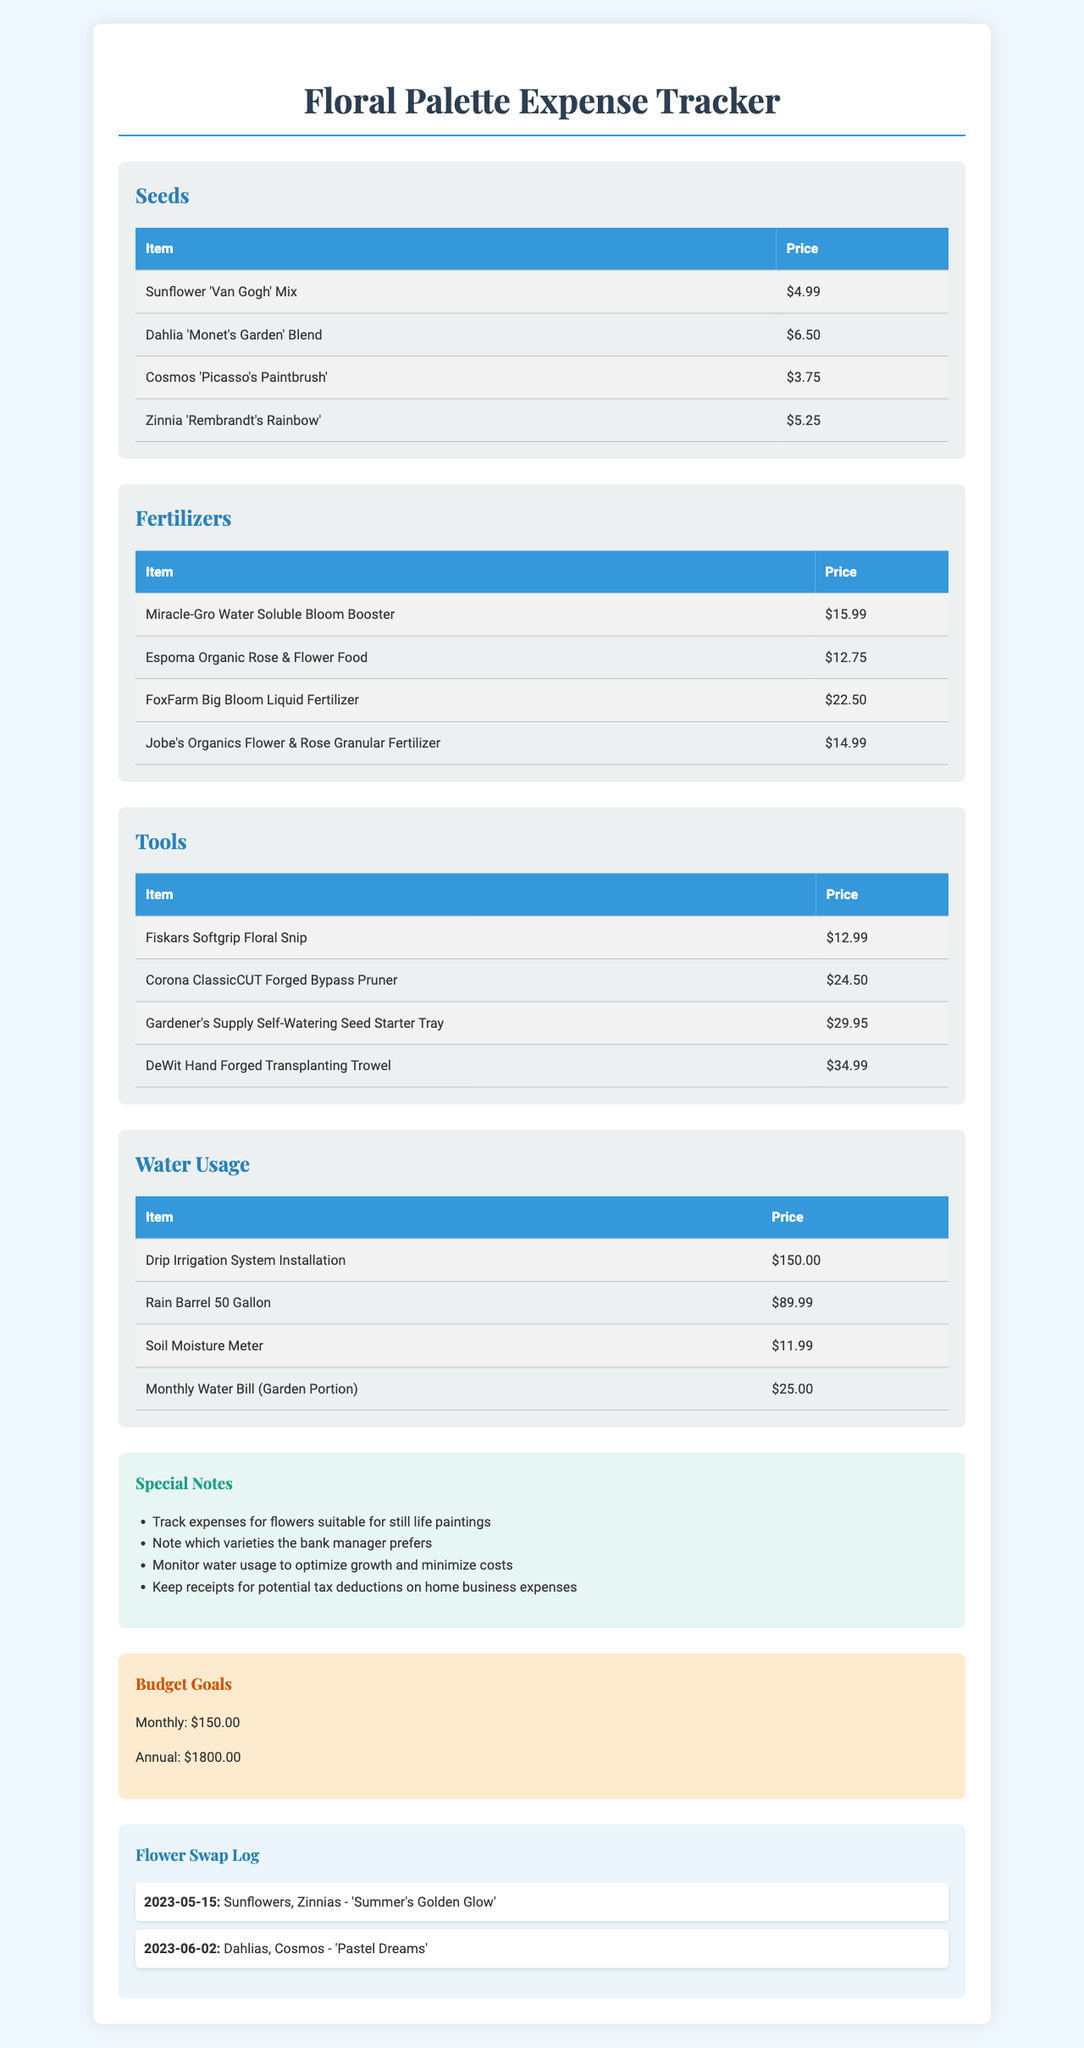What is the name of the expense tracker? The document states that the expense tracker is called "Floral Palette Expense Tracker."
Answer: Floral Palette Expense Tracker How much does the "FoxFarm Big Bloom Liquid Fertilizer" cost? The document lists the price of "FoxFarm Big Bloom Liquid Fertilizer" as $22.50.
Answer: $22.50 What is the price of the monthly water bill for the garden? The document specifies that the "Monthly Water Bill (Garden Portion)" costs $25.00.
Answer: $25.00 Which flowers were swapped on June 2, 2023? According to the flower swap log, the swapped flowers on that date are "Dahlias" and "Cosmos."
Answer: Dahlias, Cosmos What is the total budget goal for the year? The document indicates that the annual budget goal is $1800.00.
Answer: $1800.00 Which tool has the highest price listed? The highest-priced tool mentioned in the document is the "DeWit Hand Forged Transplanting Trowel," priced at $34.99.
Answer: DeWit Hand Forged Transplanting Trowel How many different fertilizers are listed? The document lists a total of four different fertilizers.
Answer: Four What is the title of the painting associated with the flower swap on May 15, 2023? The document states that the painting title for the May 15 swap is "Summer's Golden Glow."
Answer: Summer's Golden Glow What is one of the special notes mentioned in the document? The document mentions special notes to "Track expenses for flowers suitable for still life paintings."
Answer: Track expenses for flowers suitable for still life paintings 